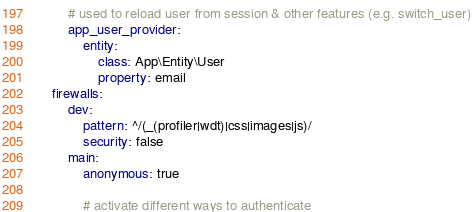Convert code to text. <code><loc_0><loc_0><loc_500><loc_500><_YAML_>        # used to reload user from session & other features (e.g. switch_user)
        app_user_provider:
            entity:
                class: App\Entity\User
                property: email
    firewalls:
        dev:
            pattern: ^/(_(profiler|wdt)|css|images|js)/
            security: false
        main:
            anonymous: true

            # activate different ways to authenticate
</code> 